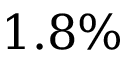<formula> <loc_0><loc_0><loc_500><loc_500>1 . 8 \%</formula> 